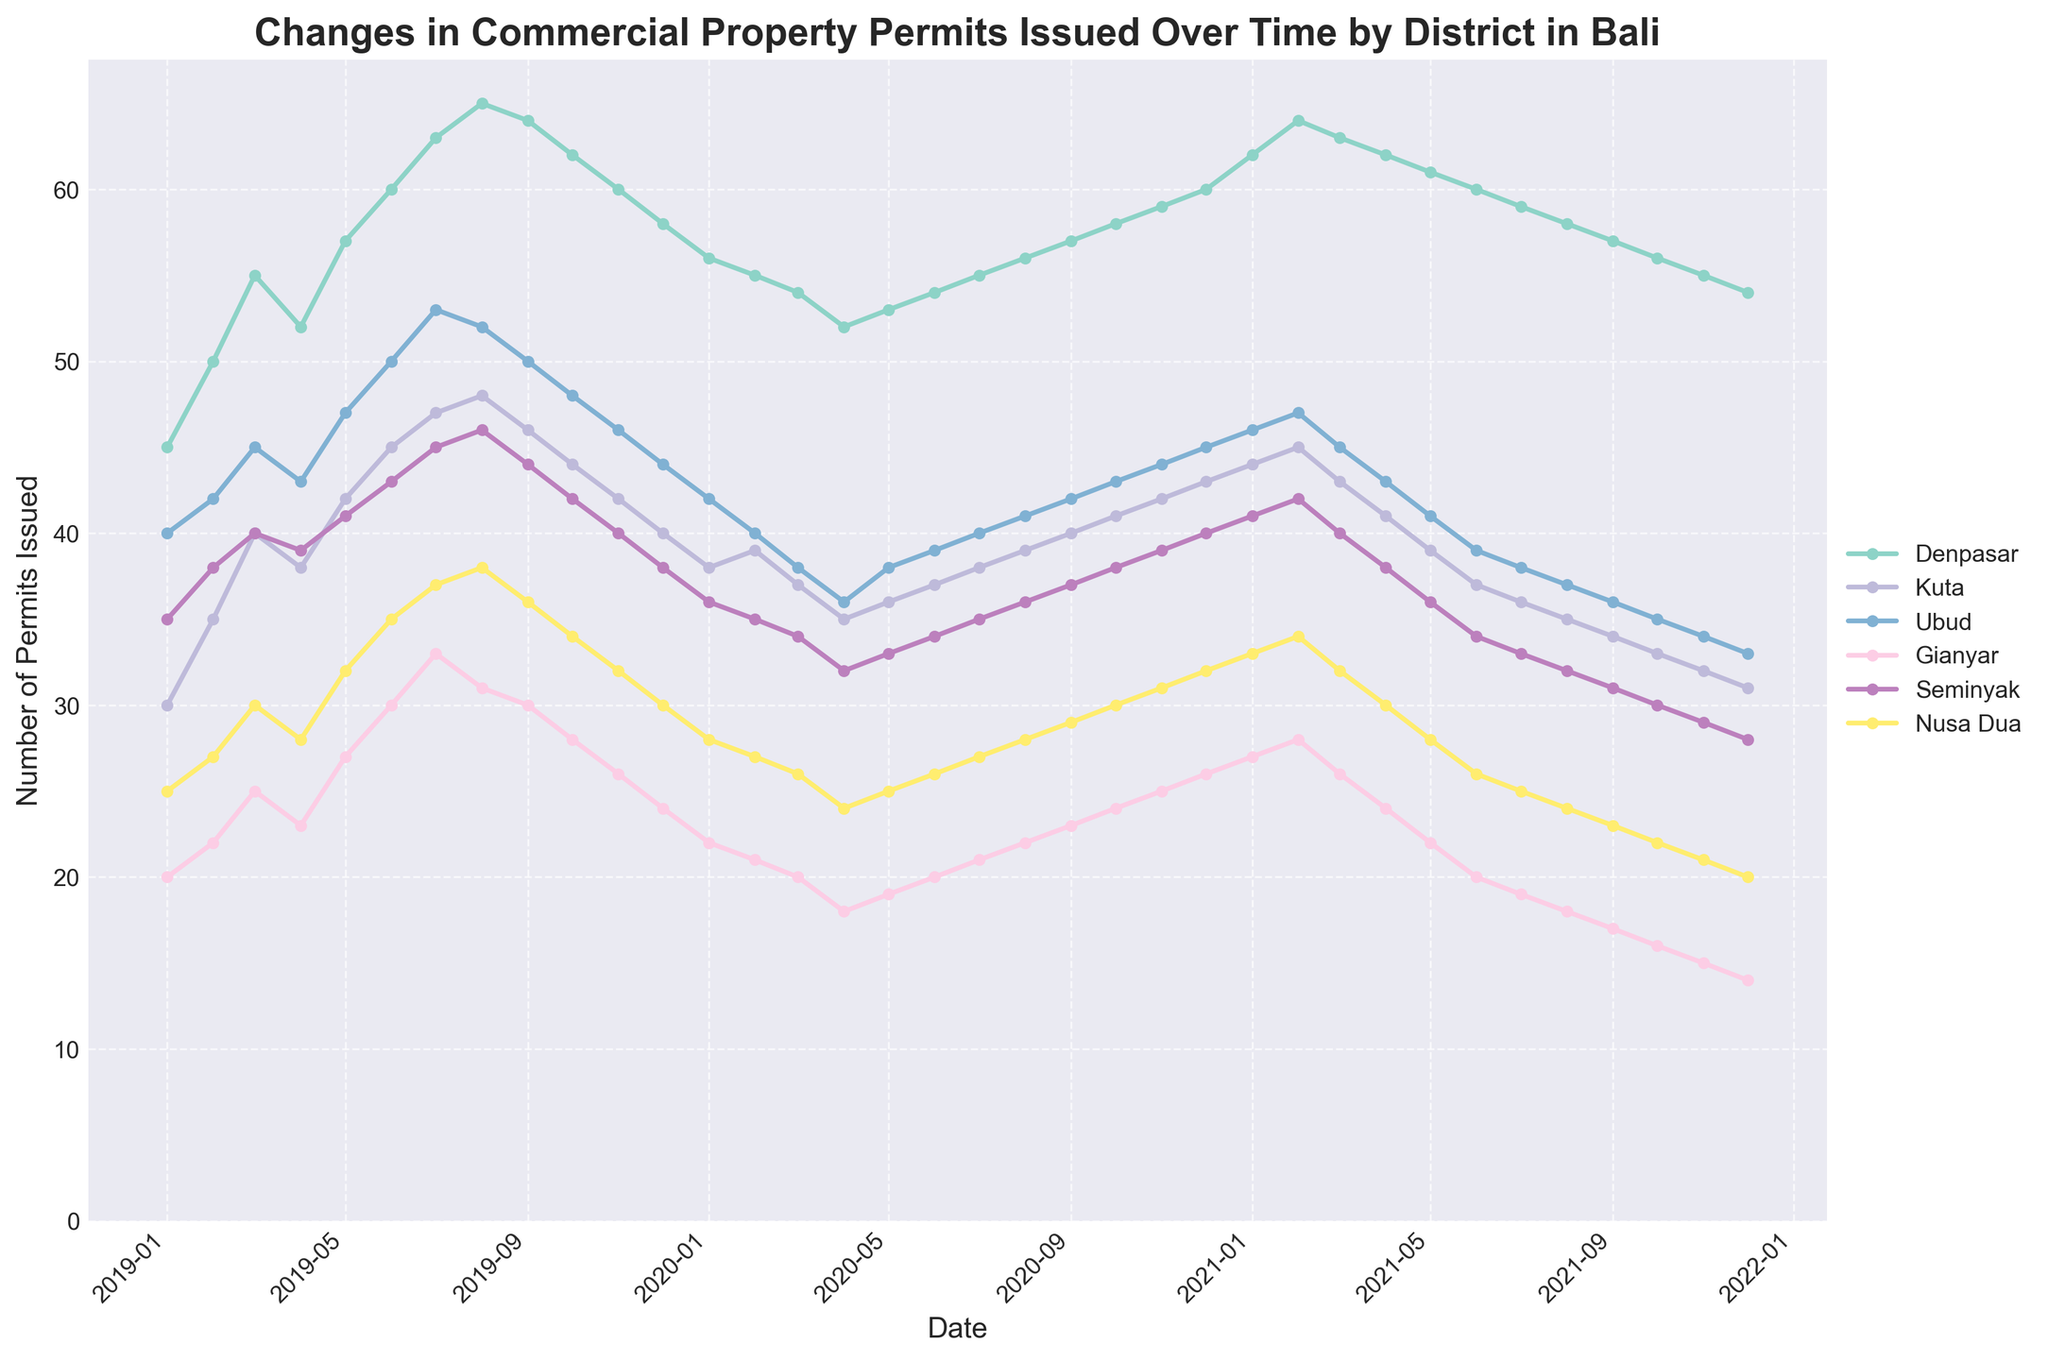Which district has the highest number of commercial property permits issued in January 2019? Look at the data points for January 2019, and identify the district with the highest value. Denpasar has 45 permits, which is the highest.
Answer: Denpasar What is the overall trend in the number of commercial property permits issued in Denpasar from 2019 to 2021? Observe the plot for Denpasar from 2019 through 2021. The line starts high in 2019, dips in 2020, and continues to decline through 2021.
Answer: Declining How many commercial property permits were issued in Kuta in July 2020? Find the data point corresponding to Kuta for July 2020. The point shows 38 permits.
Answer: 38 Which district has the most stable number of permits issued over the entire period? Look for a line that has the least fluctuation in its values from 2019 to 2021. Ubud has relatively stable values compared to more variable districts like Denpasar and Kuta.
Answer: Ubud When did Denpasar experience its peak number of permits issued? Identify the highest point in the Denpasar line on the plot. The peak occurs at July 2019.
Answer: July 2019 From the beginning to the end of 2021, how much did the number of permits in Seminyak change? Look at the Seminyak line in January 2021 (41 permits) and December 2021 (28 permits), and calculate the difference (41 - 28).
Answer: Decrease by 13 Which district saw the largest percentage decline in permits from 2019 to 2021? Calculate the percentage decline for each district from 2019 to 2021 and identify the largest. (e.g., for Denpasar: (45 - 31)/45 * 100 = 31.11%). The largest decline is in Seminyak.
Answer: Seminyak How do the permit trends in Nusa Dua compare to those in Kuta over the same period? Compare the lines for Nusa Dua and Kuta from 2019 to 2021. Both decline, but Nusa Dua shows a steadier decline whereas Kuta has more fluctuations.
Answer: Nusa Dua is steadier; Kuta is more fluctuating During the first half of 2019, which district issued the second most number of permits? Look at the data points for January through June 2019 and find the second highest value. Ubud consistently has high values, second to Denpasar.
Answer: Ubud What is the total number of permits issued in Gianyar in 2020? Sum all the data points for Gianyar's permits in 2020. (22+21+20+18+19+20+21+22+23+24+25+26) equals 261.
Answer: 261 